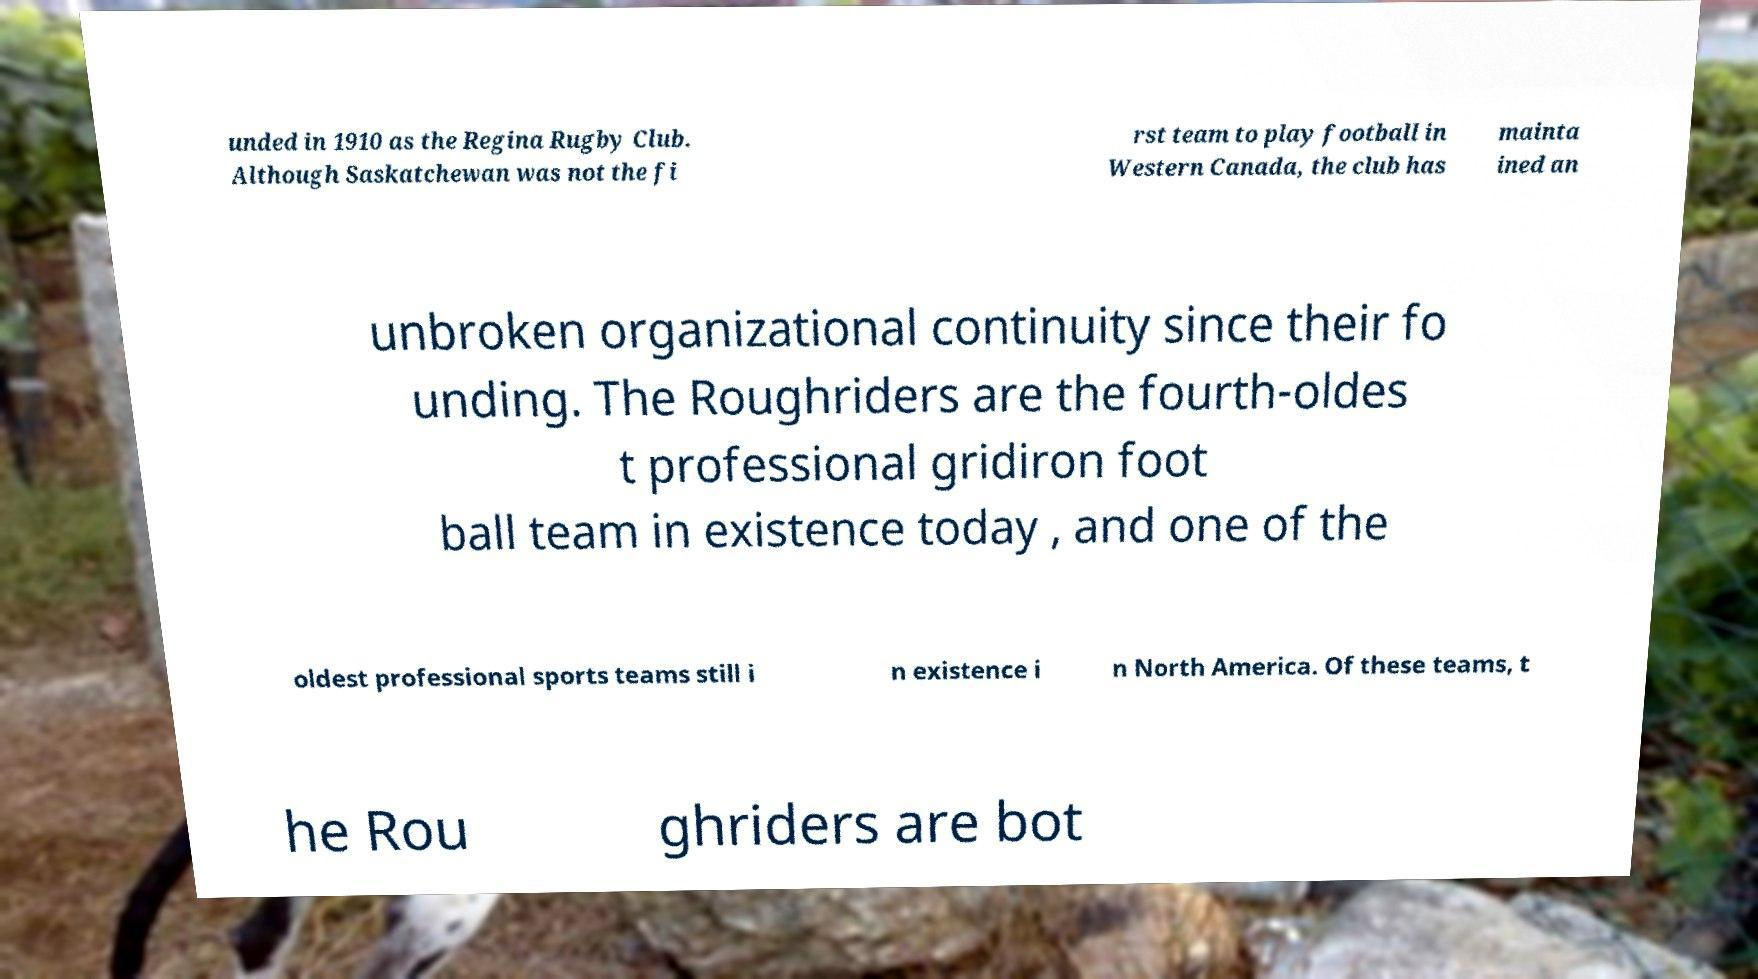Can you read and provide the text displayed in the image?This photo seems to have some interesting text. Can you extract and type it out for me? unded in 1910 as the Regina Rugby Club. Although Saskatchewan was not the fi rst team to play football in Western Canada, the club has mainta ined an unbroken organizational continuity since their fo unding. The Roughriders are the fourth-oldes t professional gridiron foot ball team in existence today , and one of the oldest professional sports teams still i n existence i n North America. Of these teams, t he Rou ghriders are bot 